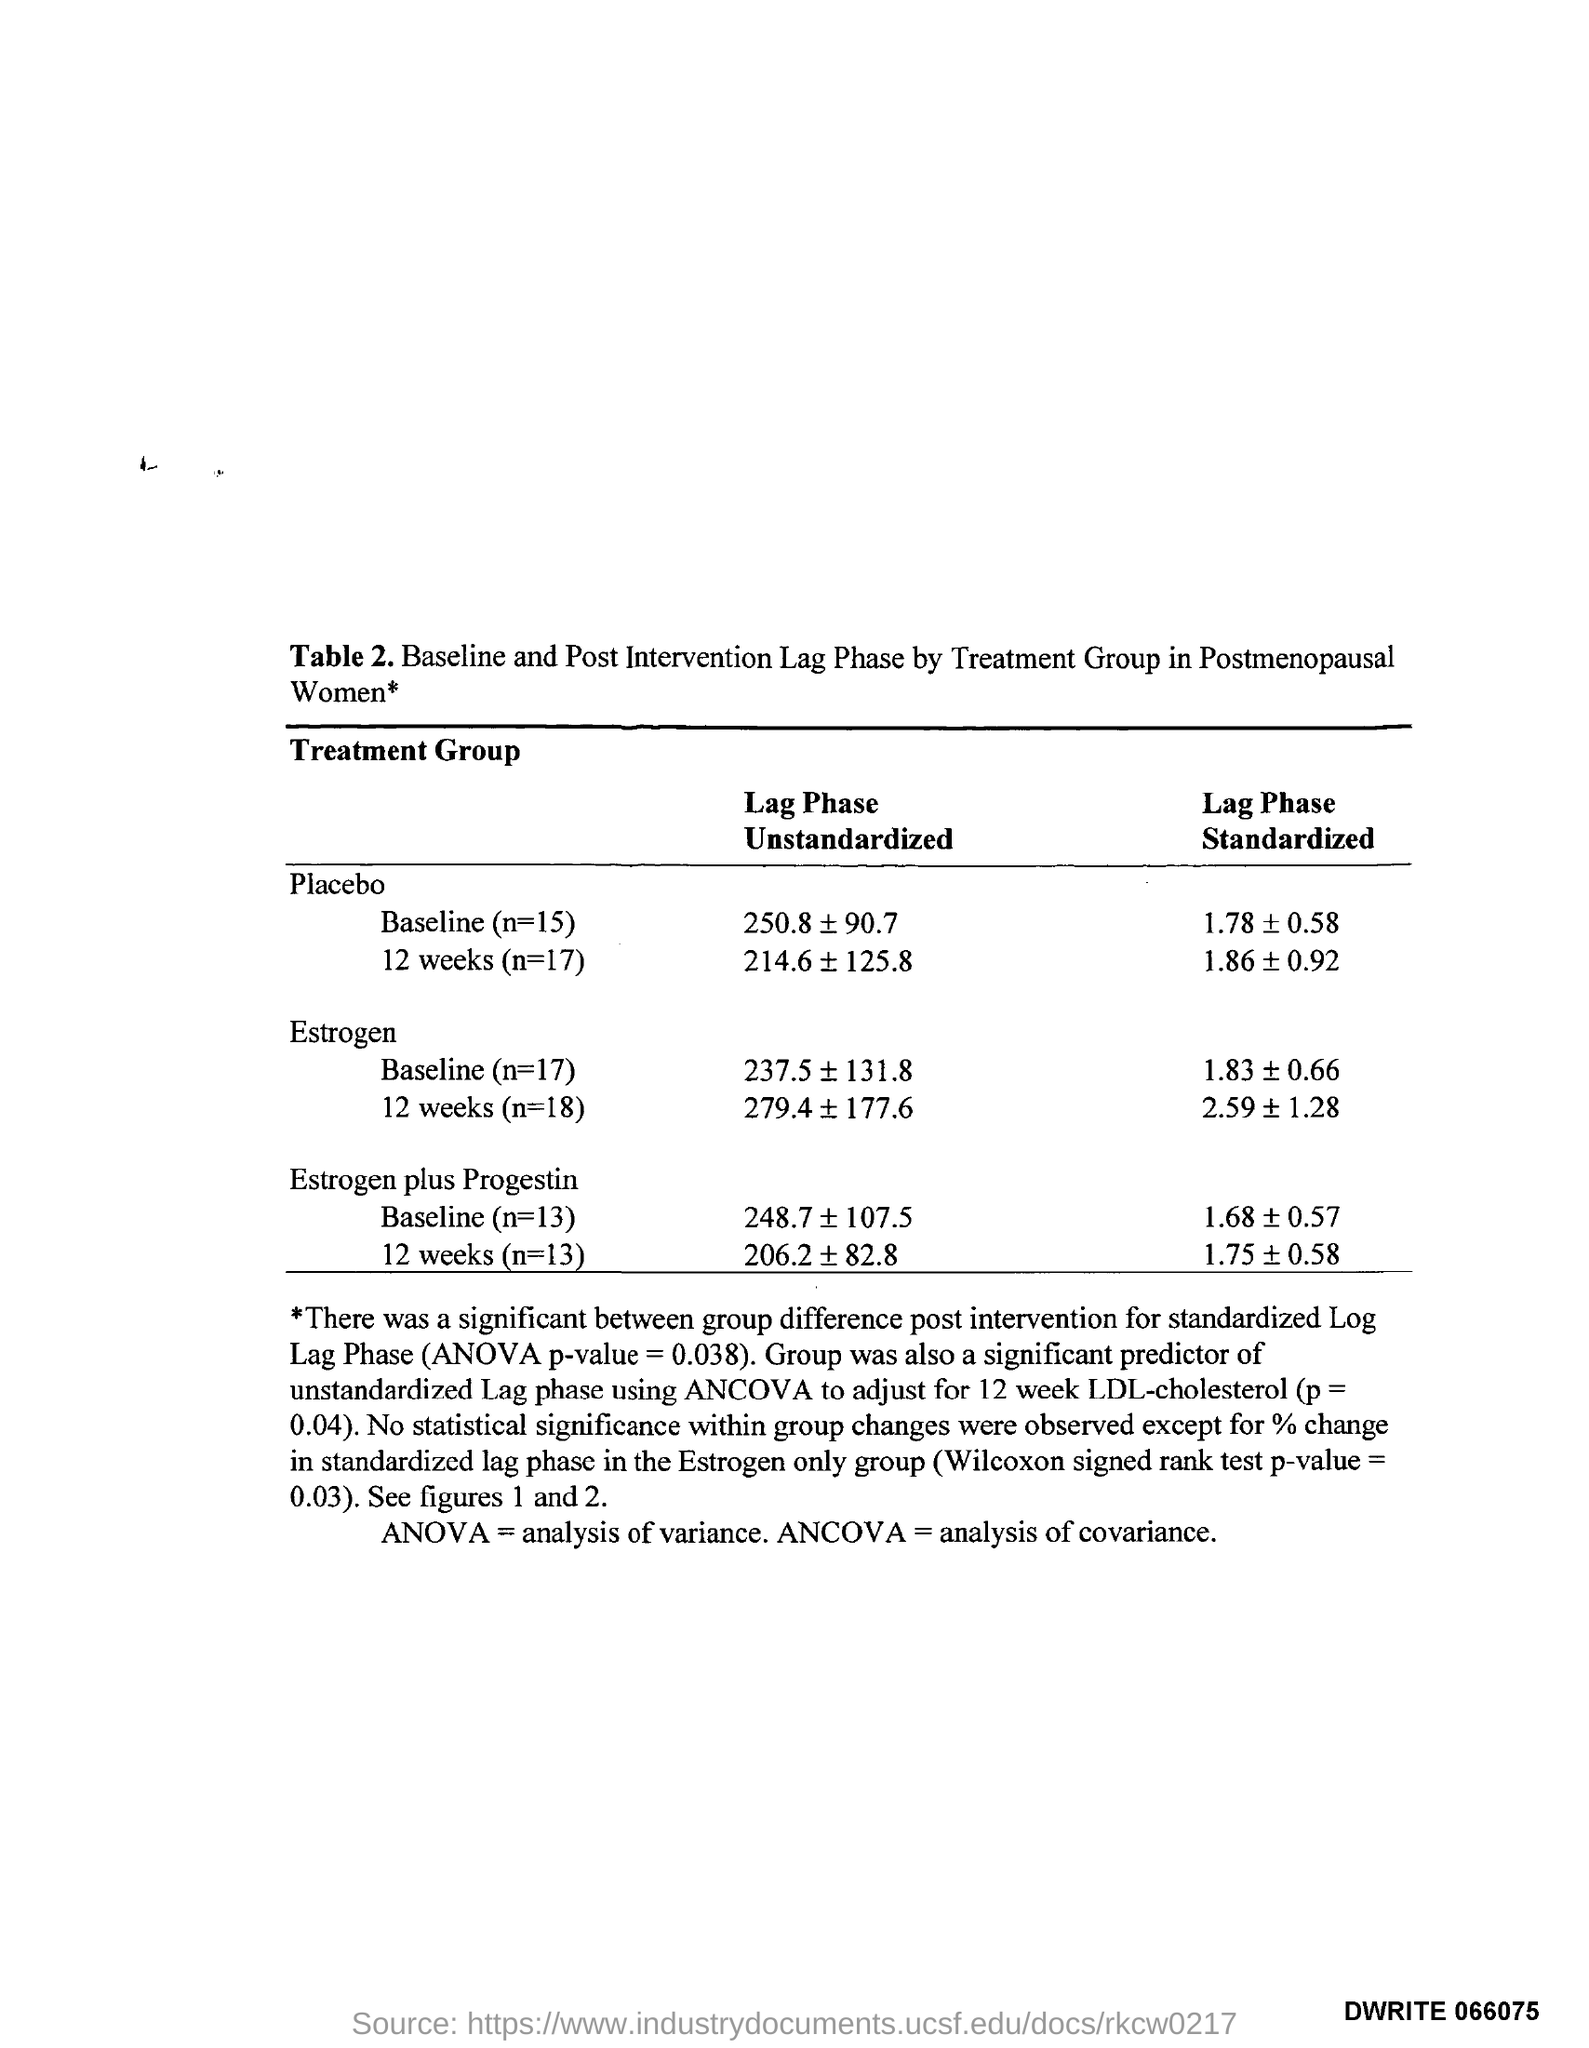What is ANOVA?
Offer a terse response. Analysis of variance. What does ANCOVA stand for?
Keep it short and to the point. Analysis of covariance. 